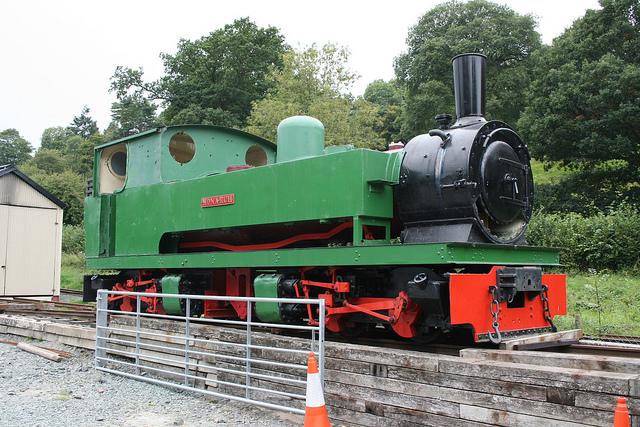What color is the train?
Quick response, please. Green. What colors are the train?
Concise answer only. Green. Is the train going off the tracks?
Keep it brief. No. How many different colors is this train?
Short answer required. 3. What is the name on the side of the train pictured?
Be succinct. Monarch. How many cars does this train have?
Write a very short answer. 1. Is the train moving?
Be succinct. No. How many flags are on the train?
Write a very short answer. 0. What type of train is this?
Quick response, please. Locomotive. How many safety cones are in the photo?
Short answer required. 2. What color is the fencing around the train yard?
Concise answer only. Silver. Does this look rusty?
Concise answer only. No. Is the train black?
Quick response, please. No. Is this a model train or a real one?
Give a very brief answer. Model. 